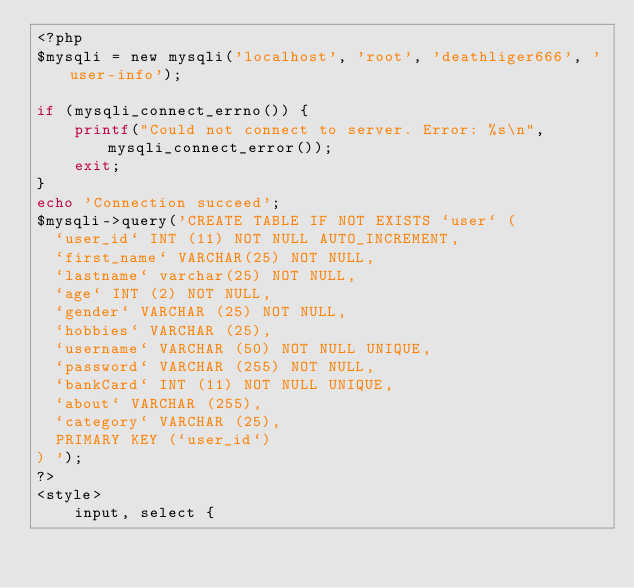Convert code to text. <code><loc_0><loc_0><loc_500><loc_500><_PHP_><?php
$mysqli = new mysqli('localhost', 'root', 'deathliger666', 'user-info');

if (mysqli_connect_errno()) {
    printf("Could not connect to server. Error: %s\n", mysqli_connect_error());
    exit;
}
echo 'Connection succeed';
$mysqli->query('CREATE TABLE IF NOT EXISTS `user` (
  `user_id` INT (11) NOT NULL AUTO_INCREMENT,
  `first_name` VARCHAR(25) NOT NULL,
  `lastname` varchar(25) NOT NULL,
  `age` INT (2) NOT NULL,
  `gender` VARCHAR (25) NOT NULL,
  `hobbies` VARCHAR (25),
  `username` VARCHAR (50) NOT NULL UNIQUE,
  `password` VARCHAR (255) NOT NULL,
  `bankCard` INT (11) NOT NULL UNIQUE,
  `about` VARCHAR (255),
  `category` VARCHAR (25),
  PRIMARY KEY (`user_id`)
) ');
?>
<style>
    input, select {</code> 